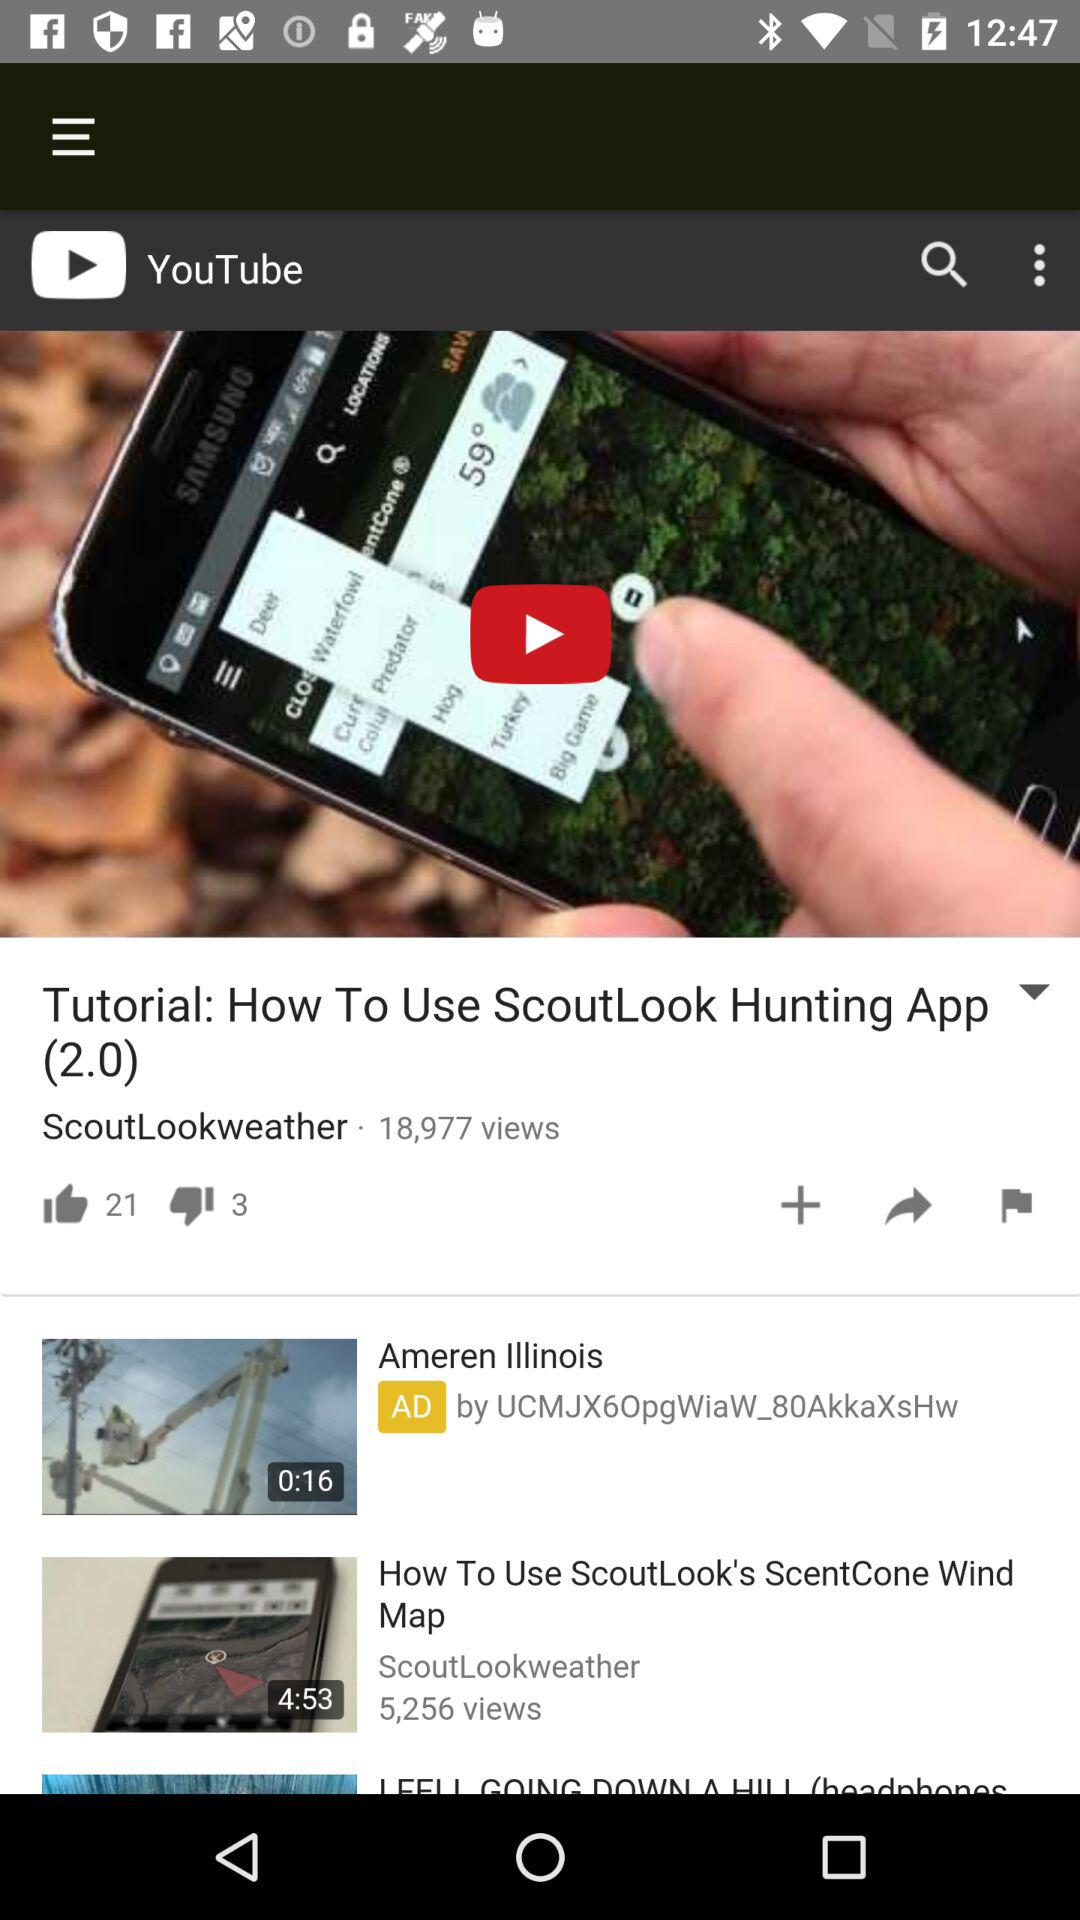What is the number of likes on "Tutorial: How To Use ScoutLook Hunting App"? The number of likes is 21. 